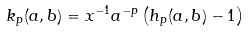Convert formula to latex. <formula><loc_0><loc_0><loc_500><loc_500>k _ { p } ( a , b ) = x ^ { - 1 } a ^ { - p } \left ( h _ { p } ( a , b ) - 1 \right )</formula> 